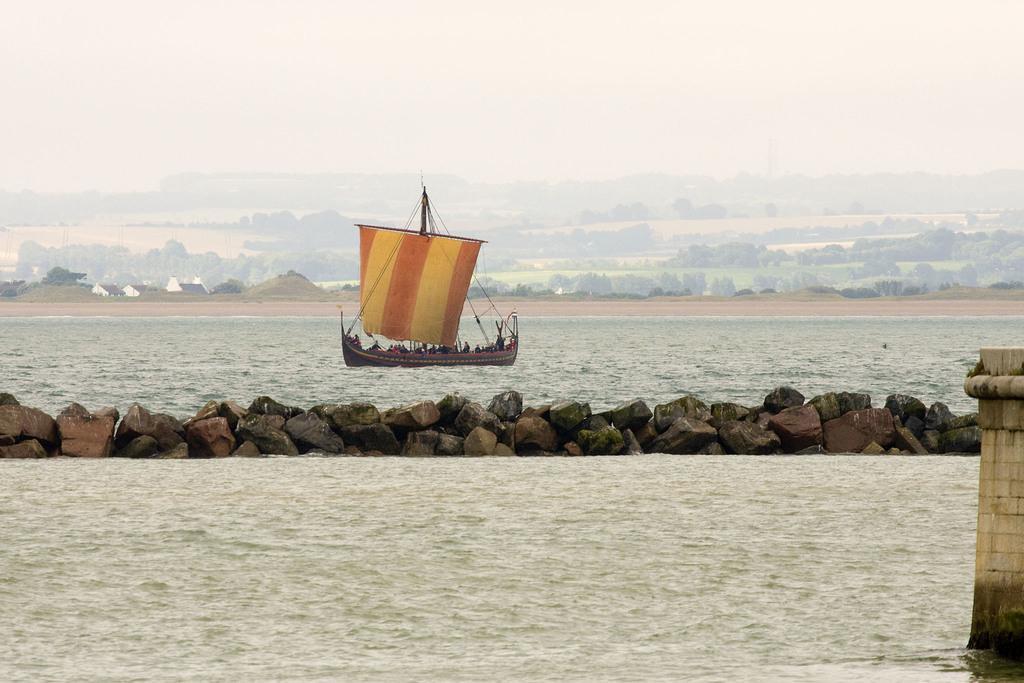In one or two sentences, can you explain what this image depicts? In this picture we can see water, wall and rocks. There are people in a boat. In the background of the image we can see trees and sky. 